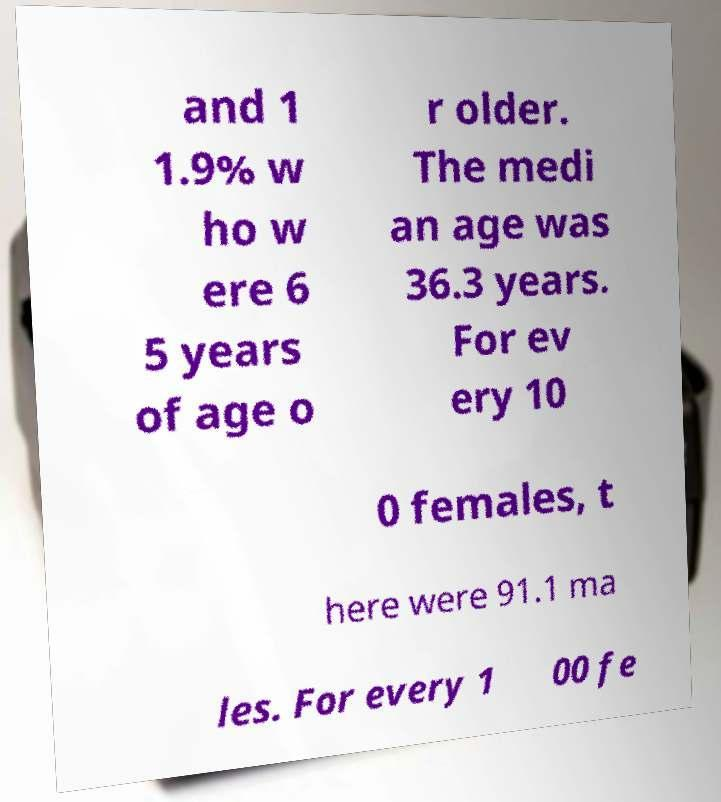Could you extract and type out the text from this image? and 1 1.9% w ho w ere 6 5 years of age o r older. The medi an age was 36.3 years. For ev ery 10 0 females, t here were 91.1 ma les. For every 1 00 fe 